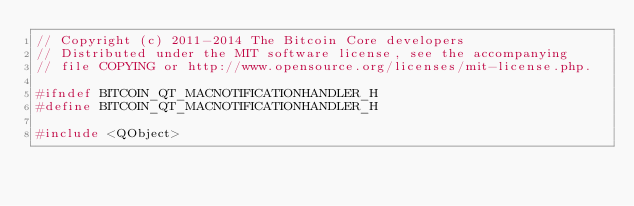Convert code to text. <code><loc_0><loc_0><loc_500><loc_500><_C_>// Copyright (c) 2011-2014 The Bitcoin Core developers
// Distributed under the MIT software license, see the accompanying
// file COPYING or http://www.opensource.org/licenses/mit-license.php.

#ifndef BITCOIN_QT_MACNOTIFICATIONHANDLER_H
#define BITCOIN_QT_MACNOTIFICATIONHANDLER_H

#include <QObject>
</code> 